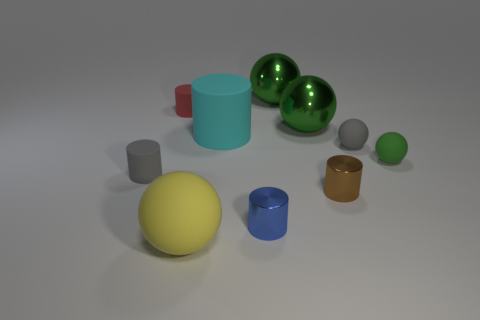What color is the small rubber ball that is left of the small green rubber thing?
Offer a very short reply. Gray. Is there a brown object of the same size as the cyan thing?
Offer a terse response. No. What material is the red object that is the same size as the green rubber thing?
Your answer should be very brief. Rubber. Does the cyan thing have the same size as the rubber ball in front of the tiny gray matte cylinder?
Provide a succinct answer. Yes. What is the cylinder that is in front of the brown metal thing made of?
Your response must be concise. Metal. Is the number of matte things in front of the red cylinder the same as the number of spheres?
Your response must be concise. Yes. Do the yellow rubber ball and the cyan thing have the same size?
Your response must be concise. Yes. There is a small green rubber thing that is in front of the big matte object that is on the right side of the big yellow sphere; is there a large thing that is behind it?
Ensure brevity in your answer.  Yes. There is a red object that is the same shape as the cyan thing; what is its material?
Make the answer very short. Rubber. What number of tiny red objects are on the left side of the cylinder in front of the small brown metallic object?
Your answer should be compact. 1. 